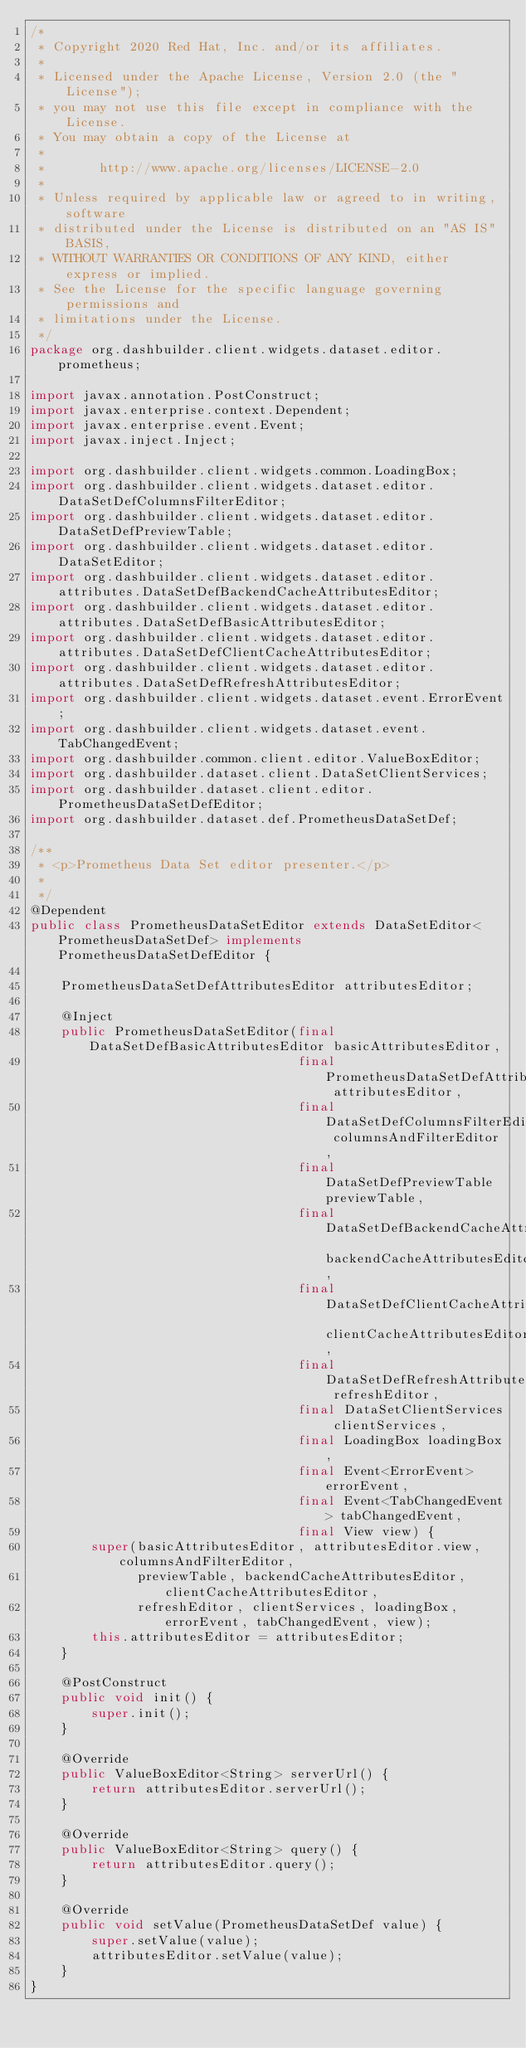Convert code to text. <code><loc_0><loc_0><loc_500><loc_500><_Java_>/*
 * Copyright 2020 Red Hat, Inc. and/or its affiliates.
 *
 * Licensed under the Apache License, Version 2.0 (the "License");
 * you may not use this file except in compliance with the License.
 * You may obtain a copy of the License at
 *
 *       http://www.apache.org/licenses/LICENSE-2.0
 *
 * Unless required by applicable law or agreed to in writing, software
 * distributed under the License is distributed on an "AS IS" BASIS,
 * WITHOUT WARRANTIES OR CONDITIONS OF ANY KIND, either express or implied.
 * See the License for the specific language governing permissions and
 * limitations under the License.
 */
package org.dashbuilder.client.widgets.dataset.editor.prometheus;

import javax.annotation.PostConstruct;
import javax.enterprise.context.Dependent;
import javax.enterprise.event.Event;
import javax.inject.Inject;

import org.dashbuilder.client.widgets.common.LoadingBox;
import org.dashbuilder.client.widgets.dataset.editor.DataSetDefColumnsFilterEditor;
import org.dashbuilder.client.widgets.dataset.editor.DataSetDefPreviewTable;
import org.dashbuilder.client.widgets.dataset.editor.DataSetEditor;
import org.dashbuilder.client.widgets.dataset.editor.attributes.DataSetDefBackendCacheAttributesEditor;
import org.dashbuilder.client.widgets.dataset.editor.attributes.DataSetDefBasicAttributesEditor;
import org.dashbuilder.client.widgets.dataset.editor.attributes.DataSetDefClientCacheAttributesEditor;
import org.dashbuilder.client.widgets.dataset.editor.attributes.DataSetDefRefreshAttributesEditor;
import org.dashbuilder.client.widgets.dataset.event.ErrorEvent;
import org.dashbuilder.client.widgets.dataset.event.TabChangedEvent;
import org.dashbuilder.common.client.editor.ValueBoxEditor;
import org.dashbuilder.dataset.client.DataSetClientServices;
import org.dashbuilder.dataset.client.editor.PrometheusDataSetDefEditor;
import org.dashbuilder.dataset.def.PrometheusDataSetDef;

/**
 * <p>Prometheus Data Set editor presenter.</p>
 * 
 */
@Dependent
public class PrometheusDataSetEditor extends DataSetEditor<PrometheusDataSetDef> implements PrometheusDataSetDefEditor {

    PrometheusDataSetDefAttributesEditor attributesEditor;

    @Inject
    public PrometheusDataSetEditor(final DataSetDefBasicAttributesEditor basicAttributesEditor,
                                   final PrometheusDataSetDefAttributesEditor attributesEditor,
                                   final DataSetDefColumnsFilterEditor columnsAndFilterEditor,
                                   final DataSetDefPreviewTable previewTable,
                                   final DataSetDefBackendCacheAttributesEditor backendCacheAttributesEditor,
                                   final DataSetDefClientCacheAttributesEditor clientCacheAttributesEditor,
                                   final DataSetDefRefreshAttributesEditor refreshEditor,
                                   final DataSetClientServices clientServices,
                                   final LoadingBox loadingBox,
                                   final Event<ErrorEvent> errorEvent,
                                   final Event<TabChangedEvent> tabChangedEvent,
                                   final View view) {
        super(basicAttributesEditor, attributesEditor.view, columnsAndFilterEditor,
              previewTable, backendCacheAttributesEditor, clientCacheAttributesEditor,
              refreshEditor, clientServices, loadingBox, errorEvent, tabChangedEvent, view);
        this.attributesEditor = attributesEditor;
    }

    @PostConstruct
    public void init() {
        super.init();
    }

    @Override
    public ValueBoxEditor<String> serverUrl() {
        return attributesEditor.serverUrl();
    }

    @Override
    public ValueBoxEditor<String> query() {
        return attributesEditor.query();
    }

    @Override
    public void setValue(PrometheusDataSetDef value) {
        super.setValue(value);
        attributesEditor.setValue(value);
    }
}</code> 